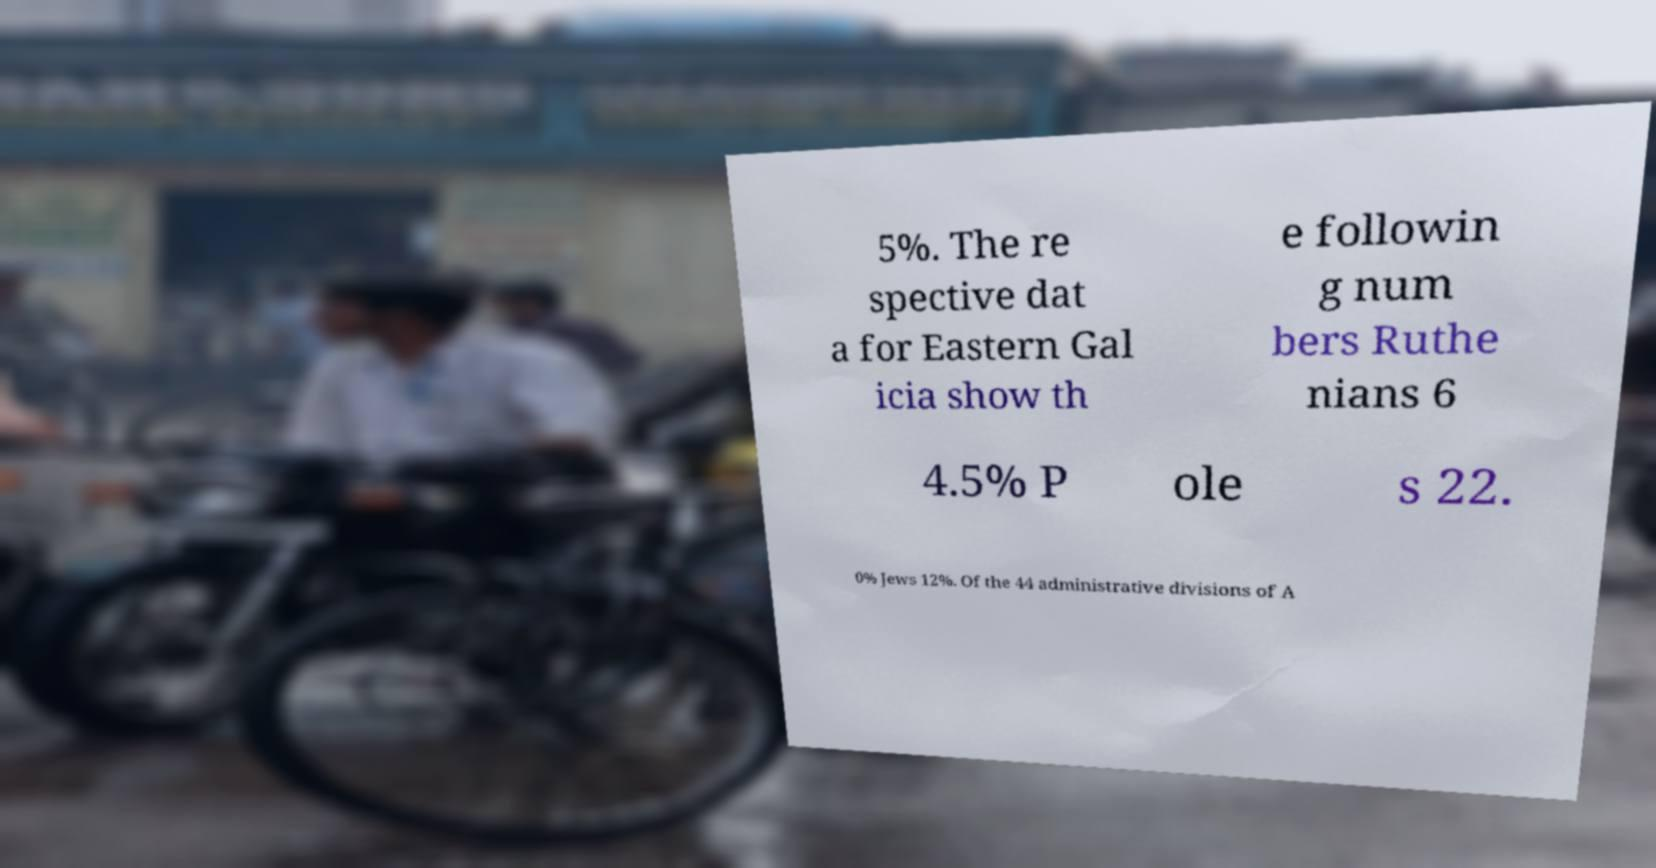Can you accurately transcribe the text from the provided image for me? 5%. The re spective dat a for Eastern Gal icia show th e followin g num bers Ruthe nians 6 4.5% P ole s 22. 0% Jews 12%. Of the 44 administrative divisions of A 